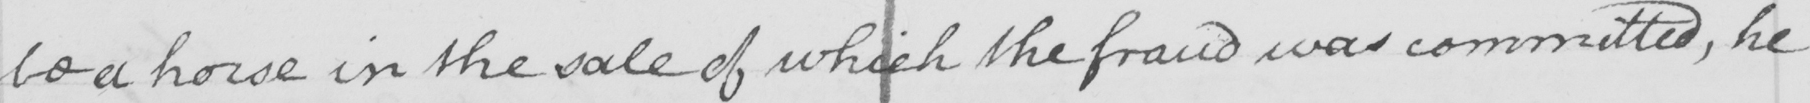Transcribe the text shown in this historical manuscript line. be a horse in the sale of which the fraud was committed , he 